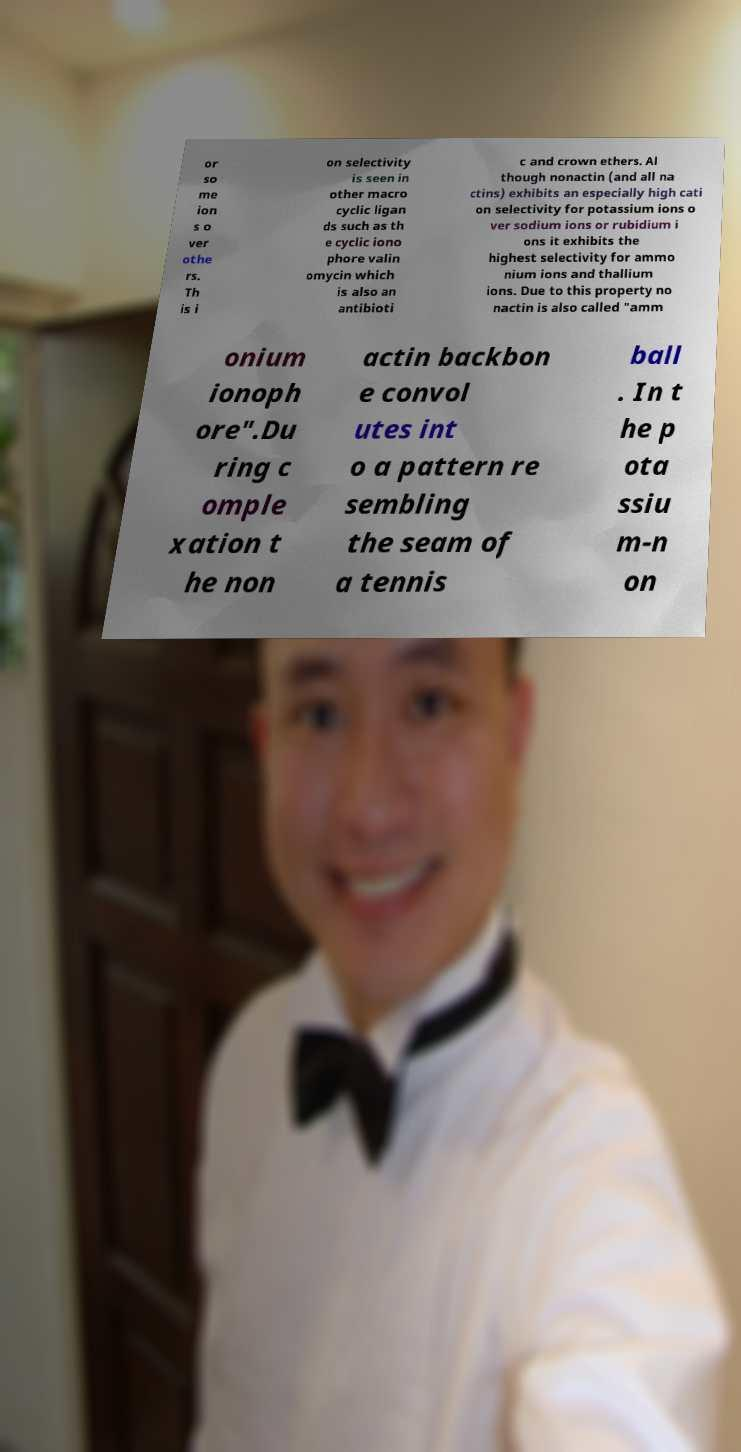Can you accurately transcribe the text from the provided image for me? or so me ion s o ver othe rs. Th is i on selectivity is seen in other macro cyclic ligan ds such as th e cyclic iono phore valin omycin which is also an antibioti c and crown ethers. Al though nonactin (and all na ctins) exhibits an especially high cati on selectivity for potassium ions o ver sodium ions or rubidium i ons it exhibits the highest selectivity for ammo nium ions and thallium ions. Due to this property no nactin is also called "amm onium ionoph ore".Du ring c omple xation t he non actin backbon e convol utes int o a pattern re sembling the seam of a tennis ball . In t he p ota ssiu m-n on 